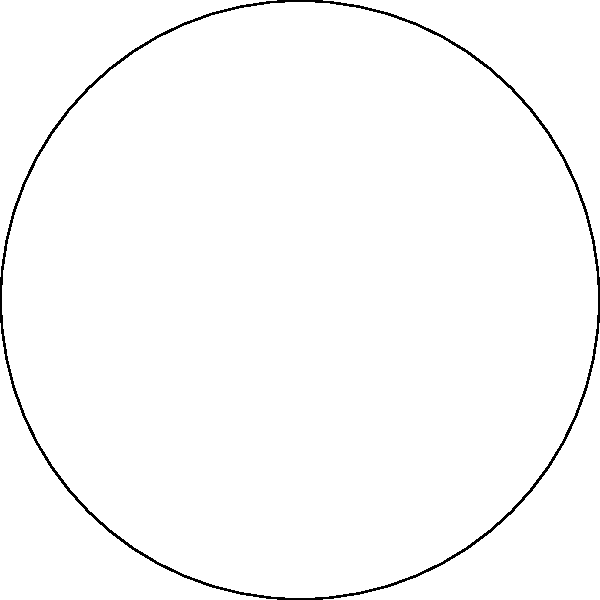In the Poincaré disk model of hyperbolic geometry shown above, three points A, B, and C form a triangle with hyperbolic lines. Which of the following statements is true about the sum of the interior angles of this hyperbolic triangle? To understand this concept, let's break it down step-by-step:

1. In Euclidean geometry, the sum of interior angles of a triangle is always 180°.

2. However, in hyperbolic geometry, this rule doesn't hold true.

3. The Poincaré disk model is a way to visualize hyperbolic geometry within a Euclidean plane.

4. In this model, straight lines in hyperbolic space are represented by arcs of circles that are orthogonal to the boundary of the disk.

5. One key property of hyperbolic geometry is that the sum of the interior angles of a triangle is always less than 180°.

6. This is because parallel lines in hyperbolic space diverge, causing the angles to be "smaller" than they would be in Euclidean space.

7. The larger the hyperbolic triangle (i.e., the closer its vertices are to the boundary of the Poincaré disk), the smaller the sum of its interior angles.

8. Conversely, as the triangle gets smaller (closer to the center of the disk), the sum of its angles approaches 180°, but never reaches or exceeds it.

Therefore, in the hyperbolic triangle ABC shown in the Poincaré disk model, the sum of the interior angles must be less than 180°.
Answer: Less than 180° 